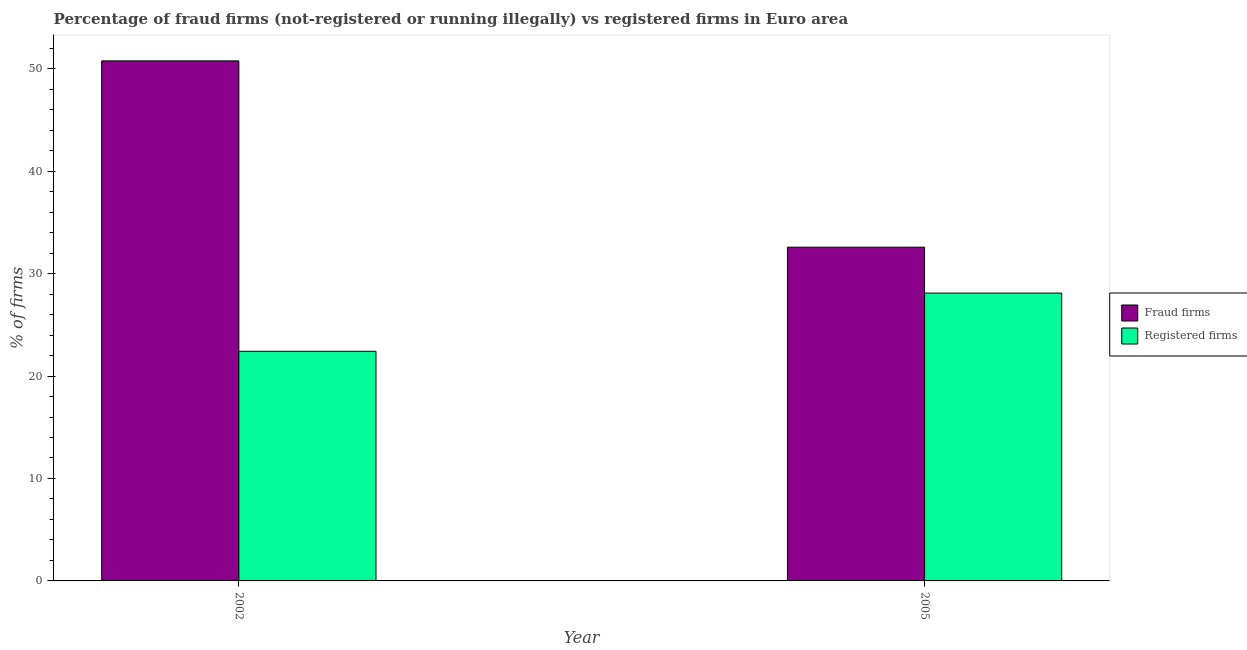How many different coloured bars are there?
Ensure brevity in your answer.  2. Are the number of bars per tick equal to the number of legend labels?
Ensure brevity in your answer.  Yes. What is the label of the 2nd group of bars from the left?
Make the answer very short. 2005. What is the percentage of registered firms in 2002?
Your response must be concise. 22.42. Across all years, what is the maximum percentage of registered firms?
Your response must be concise. 28.1. Across all years, what is the minimum percentage of fraud firms?
Make the answer very short. 32.58. In which year was the percentage of registered firms maximum?
Provide a succinct answer. 2005. What is the total percentage of fraud firms in the graph?
Offer a very short reply. 83.35. What is the difference between the percentage of registered firms in 2002 and that in 2005?
Give a very brief answer. -5.68. What is the difference between the percentage of registered firms in 2005 and the percentage of fraud firms in 2002?
Ensure brevity in your answer.  5.68. What is the average percentage of registered firms per year?
Keep it short and to the point. 25.26. In the year 2005, what is the difference between the percentage of fraud firms and percentage of registered firms?
Your answer should be compact. 0. In how many years, is the percentage of fraud firms greater than 40 %?
Offer a terse response. 1. What is the ratio of the percentage of fraud firms in 2002 to that in 2005?
Give a very brief answer. 1.56. Is the percentage of fraud firms in 2002 less than that in 2005?
Give a very brief answer. No. What does the 2nd bar from the left in 2005 represents?
Ensure brevity in your answer.  Registered firms. What does the 2nd bar from the right in 2005 represents?
Make the answer very short. Fraud firms. Are all the bars in the graph horizontal?
Ensure brevity in your answer.  No. What is the difference between two consecutive major ticks on the Y-axis?
Keep it short and to the point. 10. Are the values on the major ticks of Y-axis written in scientific E-notation?
Provide a succinct answer. No. Does the graph contain any zero values?
Ensure brevity in your answer.  No. Where does the legend appear in the graph?
Offer a very short reply. Center right. How are the legend labels stacked?
Give a very brief answer. Vertical. What is the title of the graph?
Your answer should be compact. Percentage of fraud firms (not-registered or running illegally) vs registered firms in Euro area. Does "Official creditors" appear as one of the legend labels in the graph?
Your response must be concise. No. What is the label or title of the Y-axis?
Offer a terse response. % of firms. What is the % of firms in Fraud firms in 2002?
Your answer should be compact. 50.77. What is the % of firms in Registered firms in 2002?
Offer a terse response. 22.42. What is the % of firms of Fraud firms in 2005?
Your answer should be compact. 32.58. What is the % of firms in Registered firms in 2005?
Your answer should be compact. 28.1. Across all years, what is the maximum % of firms in Fraud firms?
Your response must be concise. 50.77. Across all years, what is the maximum % of firms of Registered firms?
Make the answer very short. 28.1. Across all years, what is the minimum % of firms of Fraud firms?
Provide a short and direct response. 32.58. Across all years, what is the minimum % of firms of Registered firms?
Your answer should be very brief. 22.42. What is the total % of firms of Fraud firms in the graph?
Provide a succinct answer. 83.35. What is the total % of firms of Registered firms in the graph?
Keep it short and to the point. 50.52. What is the difference between the % of firms in Fraud firms in 2002 and that in 2005?
Ensure brevity in your answer.  18.19. What is the difference between the % of firms of Registered firms in 2002 and that in 2005?
Keep it short and to the point. -5.68. What is the difference between the % of firms of Fraud firms in 2002 and the % of firms of Registered firms in 2005?
Your response must be concise. 22.67. What is the average % of firms in Fraud firms per year?
Offer a very short reply. 41.67. What is the average % of firms of Registered firms per year?
Your response must be concise. 25.26. In the year 2002, what is the difference between the % of firms of Fraud firms and % of firms of Registered firms?
Your response must be concise. 28.35. In the year 2005, what is the difference between the % of firms of Fraud firms and % of firms of Registered firms?
Offer a terse response. 4.48. What is the ratio of the % of firms in Fraud firms in 2002 to that in 2005?
Offer a very short reply. 1.56. What is the ratio of the % of firms of Registered firms in 2002 to that in 2005?
Your response must be concise. 0.8. What is the difference between the highest and the second highest % of firms of Fraud firms?
Your answer should be very brief. 18.19. What is the difference between the highest and the second highest % of firms in Registered firms?
Your answer should be very brief. 5.68. What is the difference between the highest and the lowest % of firms in Fraud firms?
Keep it short and to the point. 18.19. What is the difference between the highest and the lowest % of firms of Registered firms?
Keep it short and to the point. 5.68. 